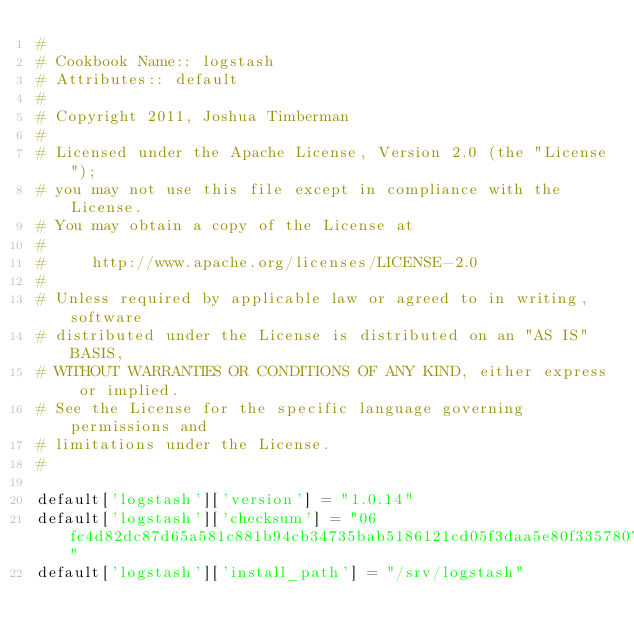<code> <loc_0><loc_0><loc_500><loc_500><_Ruby_>#
# Cookbook Name:: logstash
# Attributes:: default
#
# Copyright 2011, Joshua Timberman
#
# Licensed under the Apache License, Version 2.0 (the "License");
# you may not use this file except in compliance with the License.
# You may obtain a copy of the License at
#
#     http://www.apache.org/licenses/LICENSE-2.0
#
# Unless required by applicable law or agreed to in writing, software
# distributed under the License is distributed on an "AS IS" BASIS,
# WITHOUT WARRANTIES OR CONDITIONS OF ANY KIND, either express or implied.
# See the License for the specific language governing permissions and
# limitations under the License.
#

default['logstash']['version'] = "1.0.14"
default['logstash']['checksum'] = "06fc4d82dc87d65a581c881b94cb34735bab5186121cd05f3daa5e80f3357807"
default['logstash']['install_path'] = "/srv/logstash"
</code> 